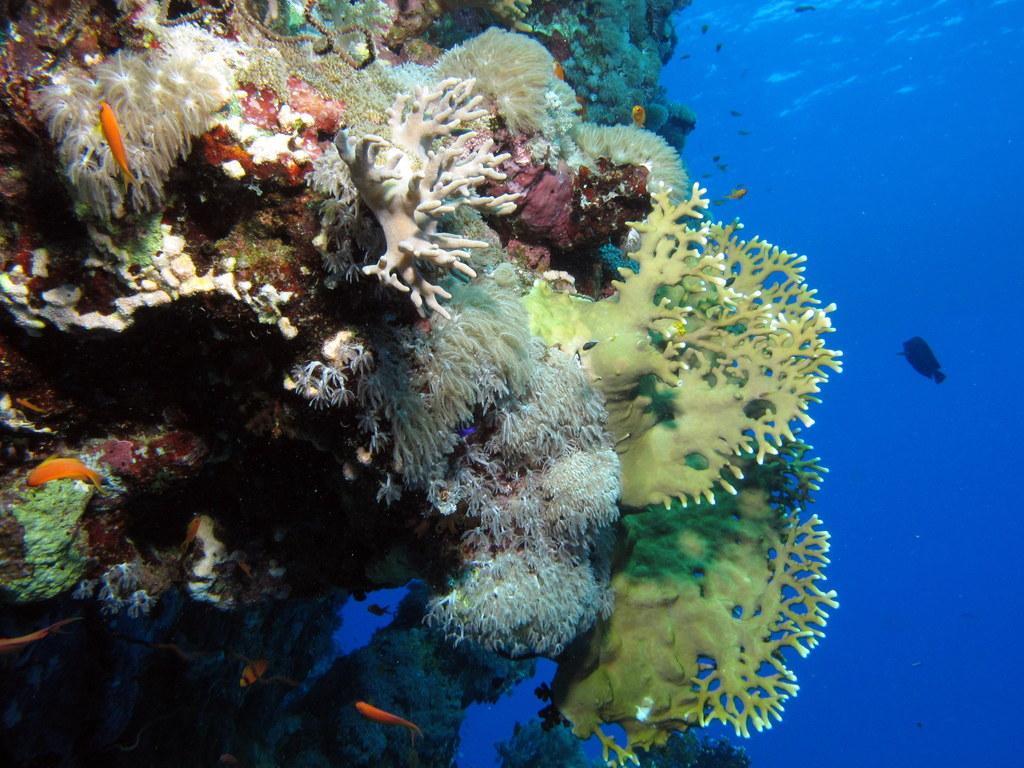Please provide a concise description of this image. In this image I can see few fishes,water in blue color and underwater garden. It is colorful. 